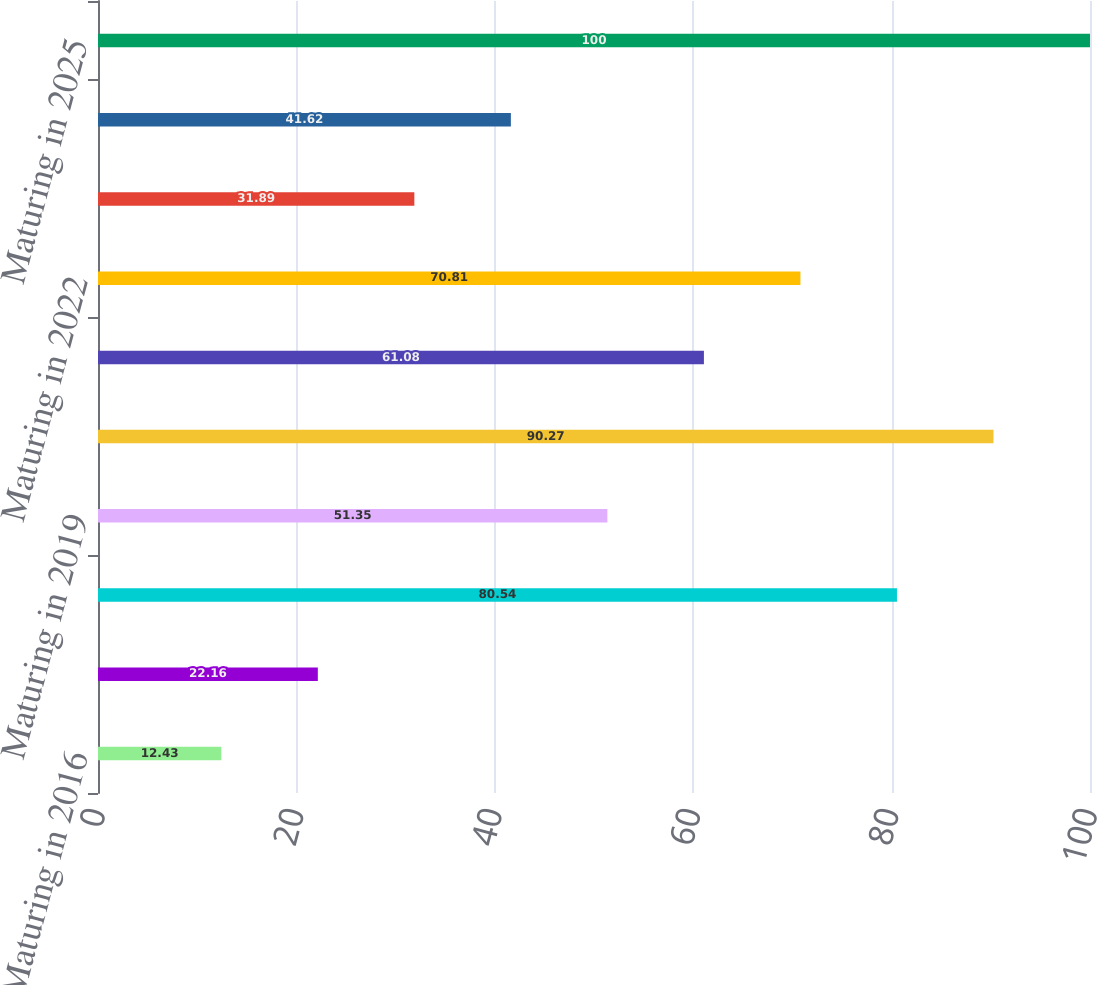Convert chart to OTSL. <chart><loc_0><loc_0><loc_500><loc_500><bar_chart><fcel>Maturing in 2016<fcel>Maturing in 2017<fcel>Maturing in 2018<fcel>Maturing in 2019<fcel>Maturing in 2020<fcel>Maturing in 2021<fcel>Maturing in 2022<fcel>Maturing in 2023<fcel>Maturing in 2024<fcel>Maturing in 2025<nl><fcel>12.43<fcel>22.16<fcel>80.54<fcel>51.35<fcel>90.27<fcel>61.08<fcel>70.81<fcel>31.89<fcel>41.62<fcel>100<nl></chart> 